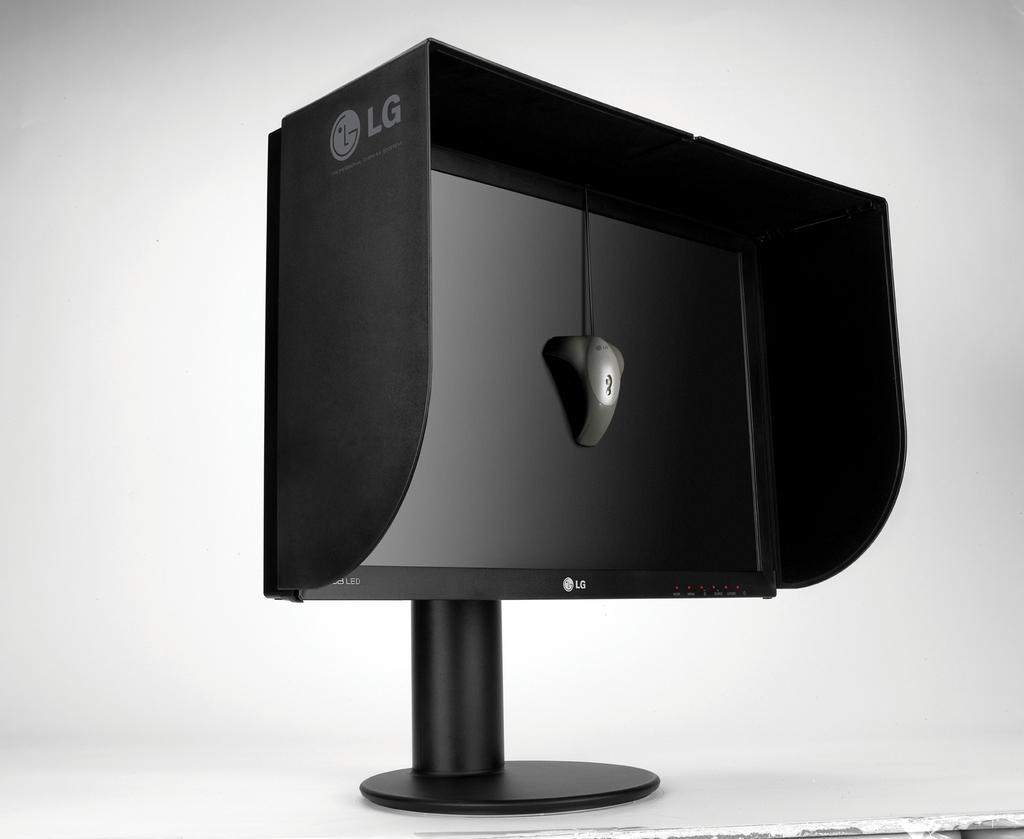What brand of electronics is shown?
Give a very brief answer. Lg. 